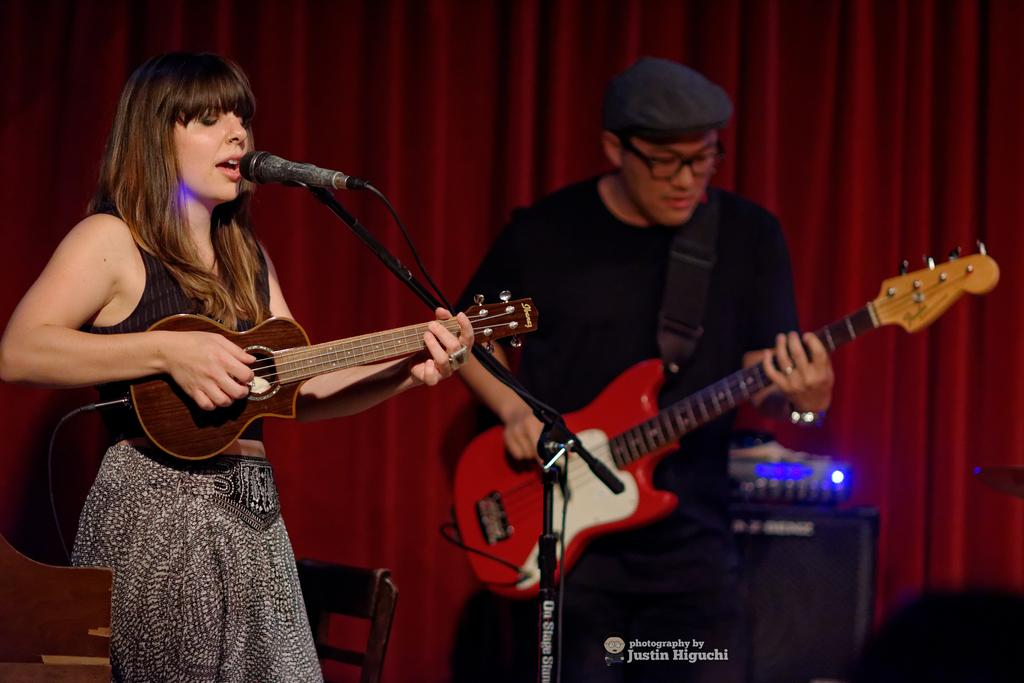How many people are in the image? There are two people in the image. What are the people doing in the image? Both people are playing the guitar. Can you describe the position of one of the people? One person is standing in front of a mic. What can be seen in the background of the image? There is a curtain in the background of the image. What type of bead is hanging from the guitar in the image? There is no bead hanging from the guitar in the image. Can you describe the picture on the curtain in the background? There is no picture visible on the curtain in the image. 